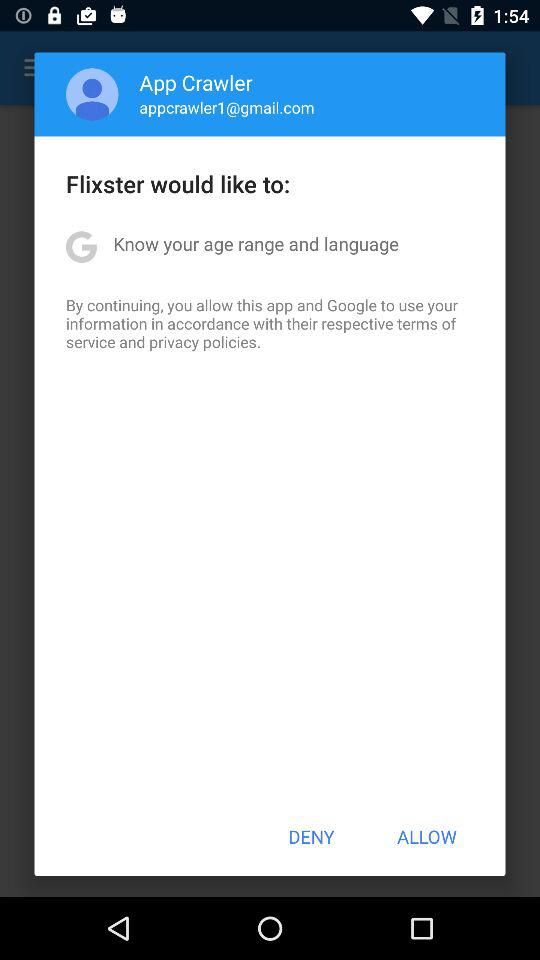What application would like to know the age range? The application is "Flixster". 